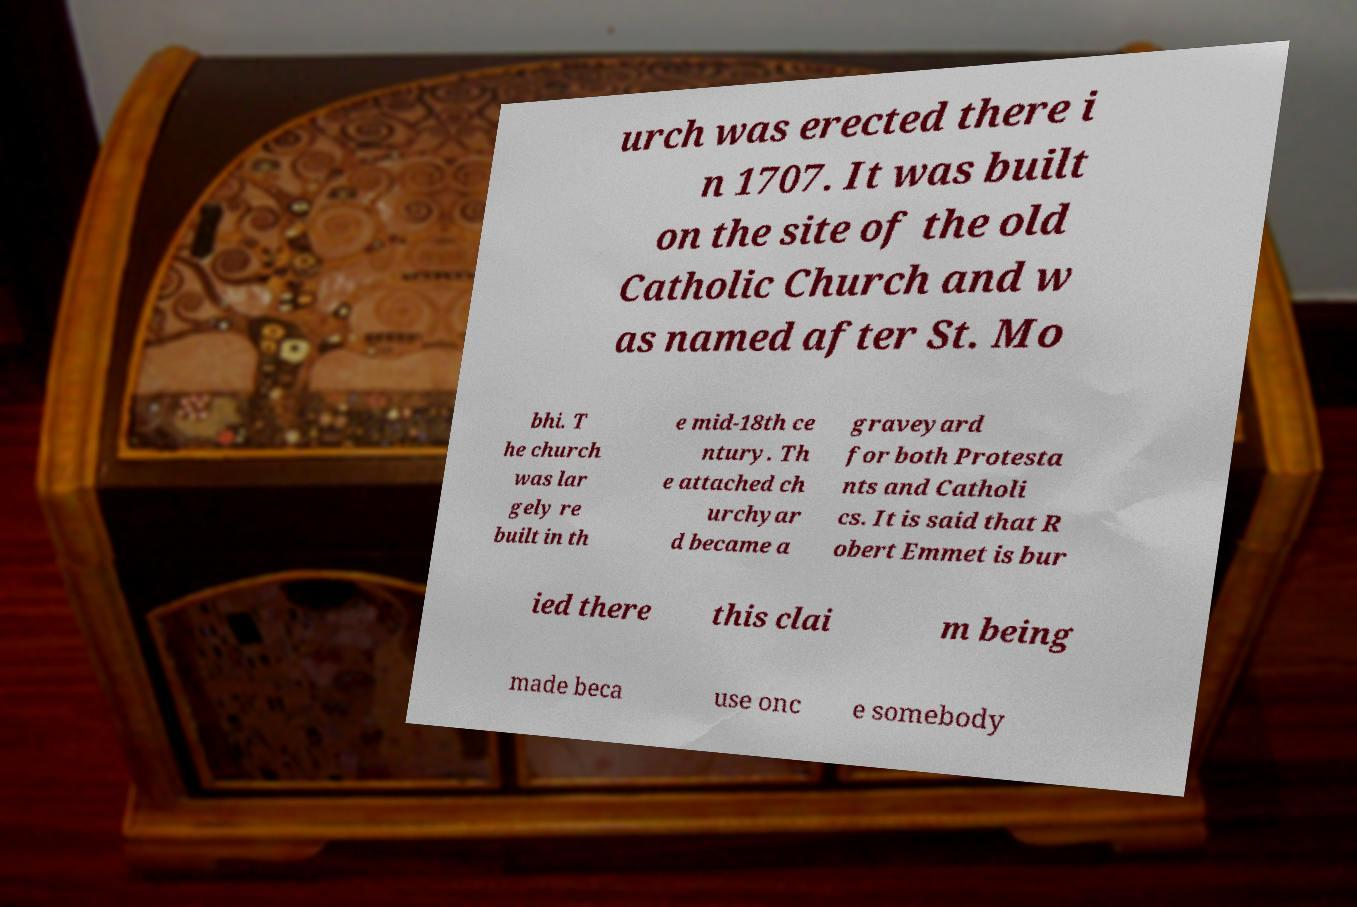I need the written content from this picture converted into text. Can you do that? urch was erected there i n 1707. It was built on the site of the old Catholic Church and w as named after St. Mo bhi. T he church was lar gely re built in th e mid-18th ce ntury. Th e attached ch urchyar d became a graveyard for both Protesta nts and Catholi cs. It is said that R obert Emmet is bur ied there this clai m being made beca use onc e somebody 